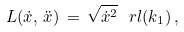<formula> <loc_0><loc_0><loc_500><loc_500>L ( \dot { x } , \, \ddot { x } ) \, = \, \sqrt { \dot { x } ^ { 2 } } \, \ r l ( k _ { 1 } ) \, { , }</formula> 